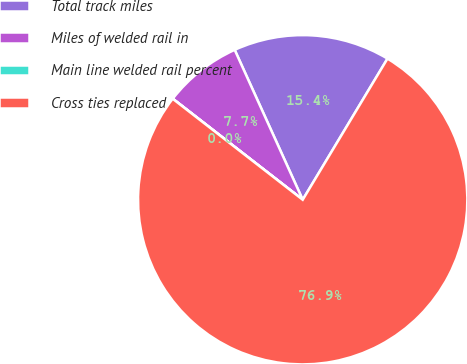<chart> <loc_0><loc_0><loc_500><loc_500><pie_chart><fcel>Total track miles<fcel>Miles of welded rail in<fcel>Main line welded rail percent<fcel>Cross ties replaced<nl><fcel>15.39%<fcel>7.7%<fcel>0.01%<fcel>76.9%<nl></chart> 